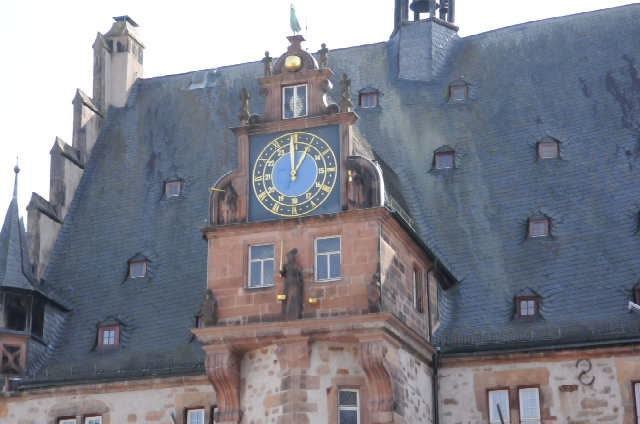Describe the objects in this image and their specific colors. I can see a clock in white, darkgray, and gray tones in this image. 